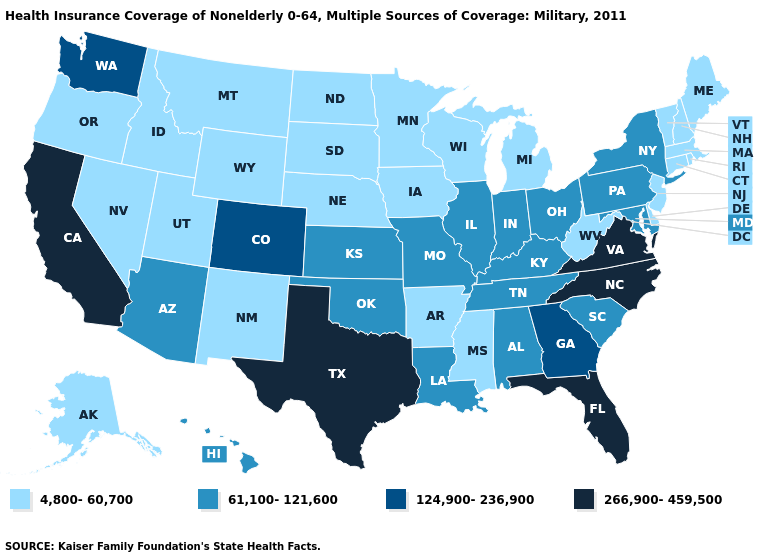What is the lowest value in the USA?
Answer briefly. 4,800-60,700. What is the value of Tennessee?
Answer briefly. 61,100-121,600. Name the states that have a value in the range 61,100-121,600?
Give a very brief answer. Alabama, Arizona, Hawaii, Illinois, Indiana, Kansas, Kentucky, Louisiana, Maryland, Missouri, New York, Ohio, Oklahoma, Pennsylvania, South Carolina, Tennessee. Does Ohio have the lowest value in the MidWest?
Answer briefly. No. What is the value of Minnesota?
Concise answer only. 4,800-60,700. Which states hav the highest value in the South?
Answer briefly. Florida, North Carolina, Texas, Virginia. Which states have the lowest value in the West?
Be succinct. Alaska, Idaho, Montana, Nevada, New Mexico, Oregon, Utah, Wyoming. Name the states that have a value in the range 266,900-459,500?
Give a very brief answer. California, Florida, North Carolina, Texas, Virginia. What is the value of Massachusetts?
Be succinct. 4,800-60,700. Name the states that have a value in the range 266,900-459,500?
Short answer required. California, Florida, North Carolina, Texas, Virginia. Does the map have missing data?
Keep it brief. No. Does Virginia have the highest value in the USA?
Concise answer only. Yes. What is the value of Colorado?
Concise answer only. 124,900-236,900. What is the lowest value in the South?
Answer briefly. 4,800-60,700. What is the value of Montana?
Write a very short answer. 4,800-60,700. 